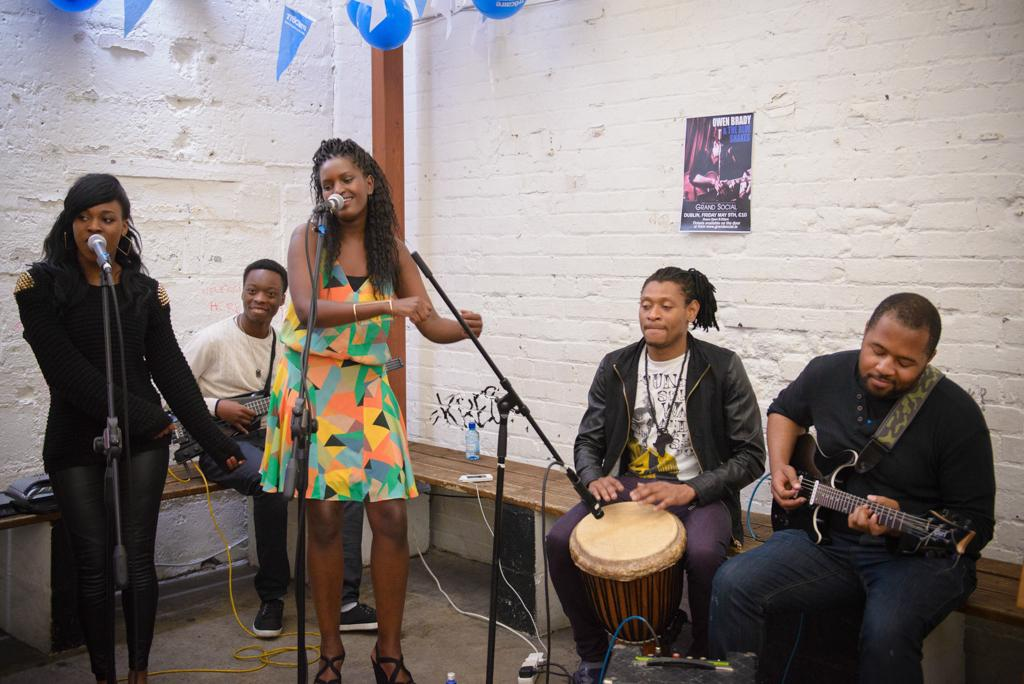How many people are present in the image? There are five people in the image. What are some of the people doing in the image? Some of the people are sitting, and some are playing musical instruments. Can you describe the positions of the ladies in the image? Two ladies are standing in front of microphones. What type of caption is written on the doll in the image? There is no doll present in the image, so there is no caption to describe. 